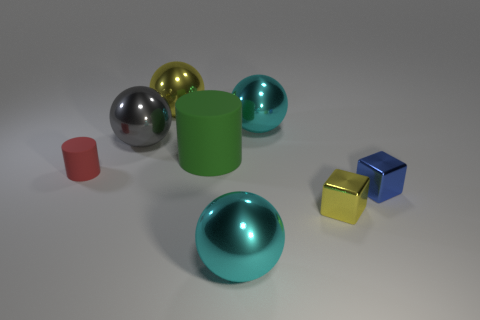How many other things are there of the same size as the yellow sphere?
Keep it short and to the point. 4. How big is the cylinder to the right of the tiny cylinder?
Your answer should be very brief. Large. What is the shape of the small object that is the same material as the big cylinder?
Your answer should be compact. Cylinder. Is there anything else that is the same color as the large rubber cylinder?
Your answer should be very brief. No. What color is the big metal ball to the right of the large metallic object in front of the small red cylinder?
Your answer should be very brief. Cyan. What number of big objects are either blue objects or metallic blocks?
Offer a terse response. 0. There is a blue object that is the same shape as the tiny yellow object; what is its material?
Ensure brevity in your answer.  Metal. What color is the small matte thing?
Keep it short and to the point. Red. There is a large cyan object that is behind the gray shiny thing; what number of red things are on the left side of it?
Offer a terse response. 1. There is a shiny object that is behind the gray ball and in front of the large yellow object; what is its size?
Offer a very short reply. Large. 